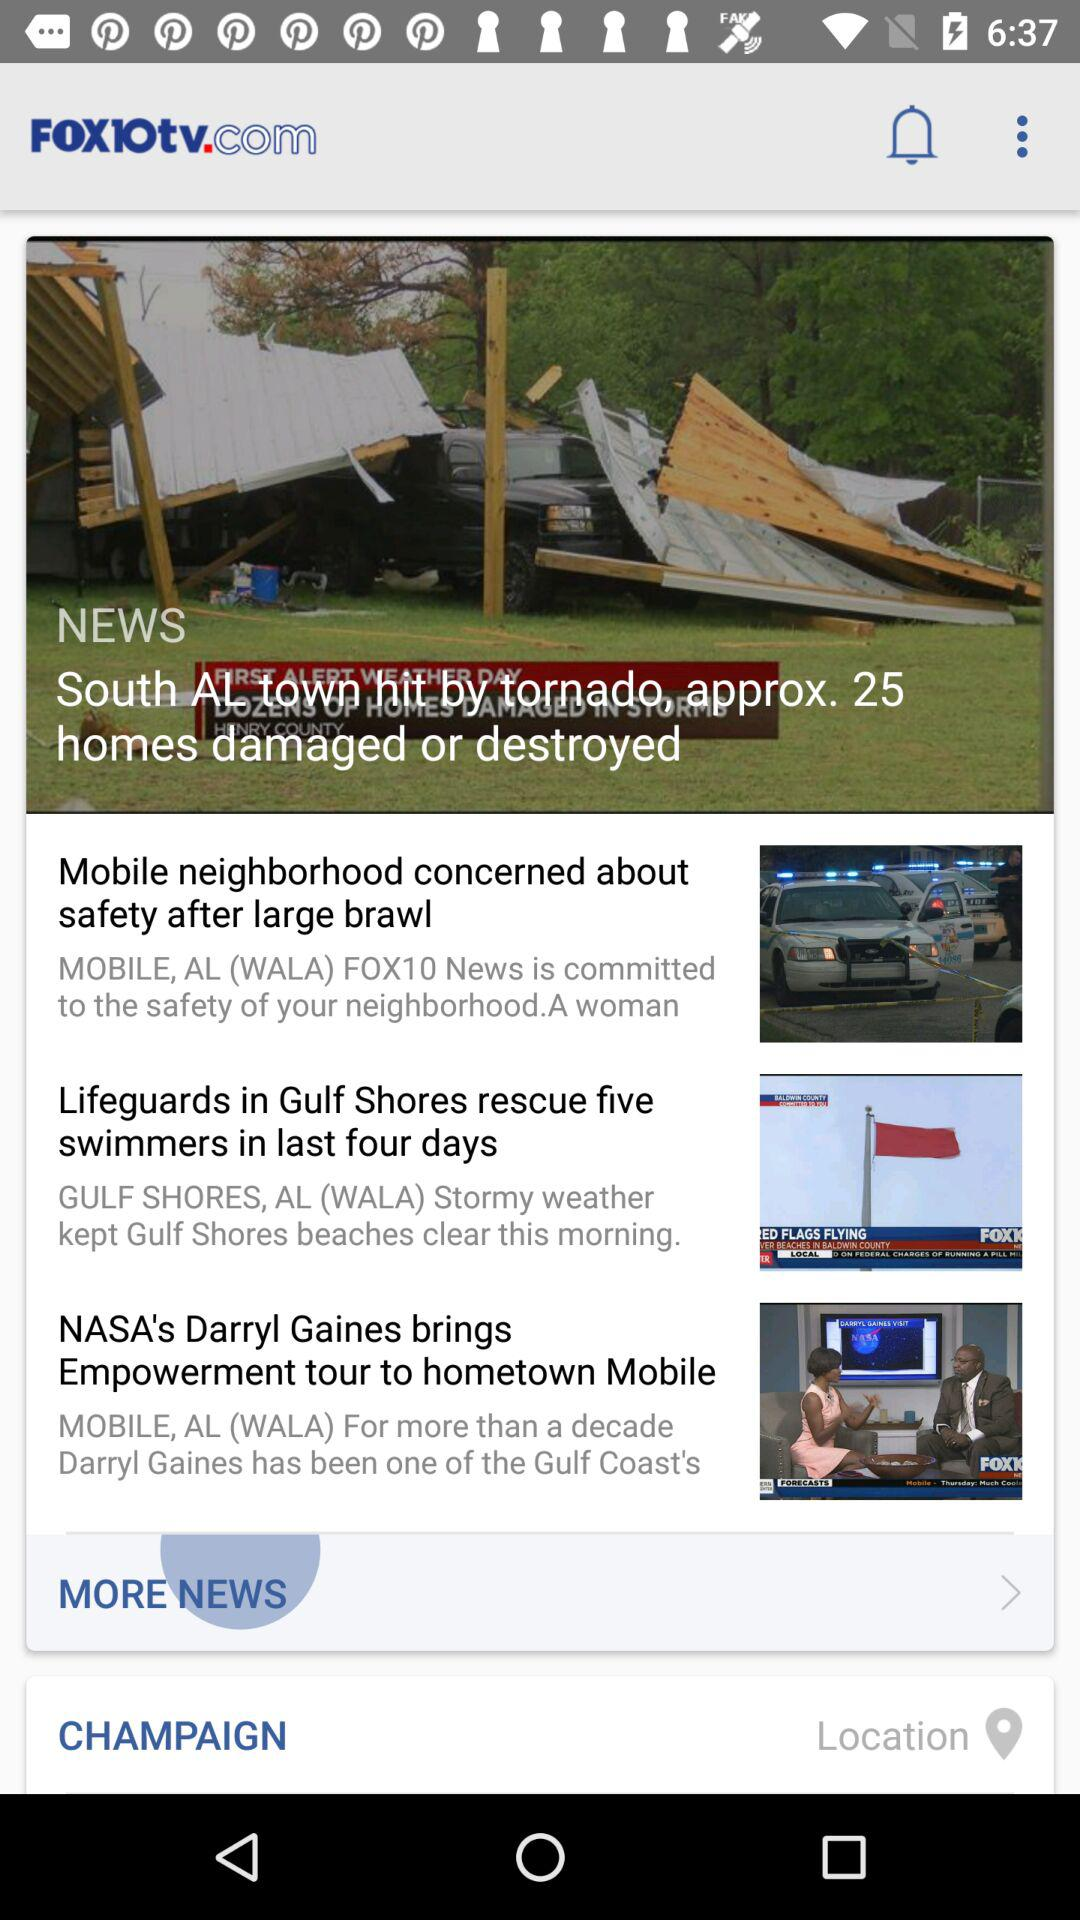In which state is Champaign?
When the provided information is insufficient, respond with <no answer>. <no answer> 